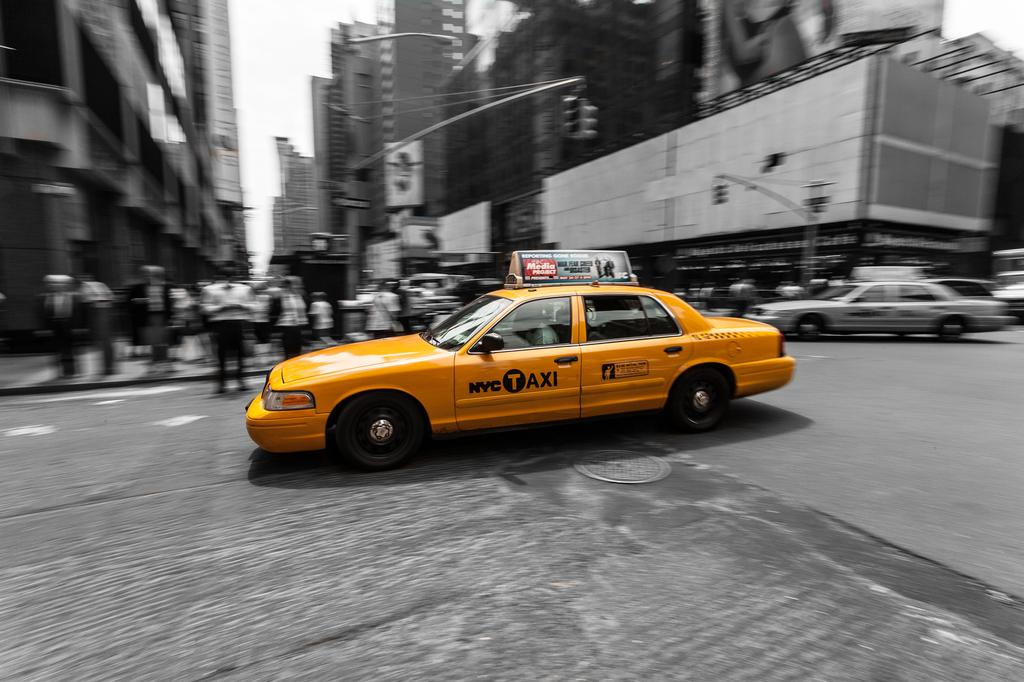<image>
Provide a brief description of the given image. a taxi that has a media ad on the top 